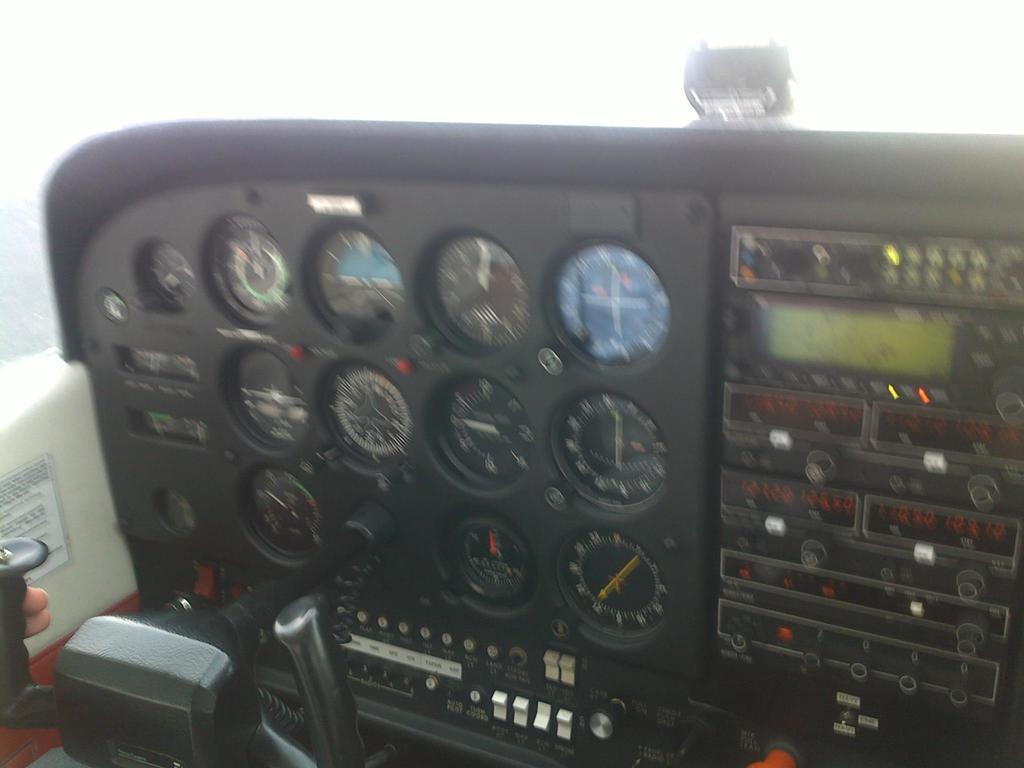Describe this image in one or two sentences. In this image, I can see gauges, devices, switches and a control yoke in an aircraft. At the bottom left side of the image, I can see fingers of a person. 